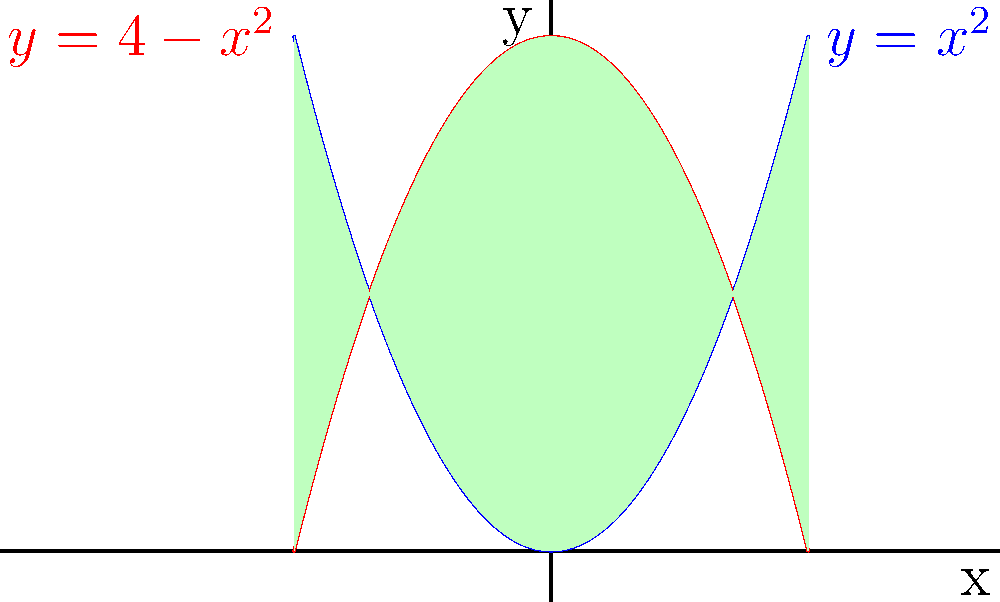At a multicultural school event, you're helping your immigrant friend understand a math problem. The problem involves two parabolas: $y=x^2$ and $y=4-x^2$. What's the area of the region bounded by these two intersecting parabolas? Let's approach this step-by-step:

1) First, we need to find the points of intersection of the two parabolas:
   $x^2 = 4-x^2$
   $2x^2 = 4$
   $x^2 = 2$
   $x = \pm\sqrt{2}$

2) The points of intersection are $(-\sqrt{2},2)$ and $(\sqrt{2},2)$.

3) The area we're looking for is the difference between the integral of the upper function $(4-x^2)$ and the lower function $(x^2)$ from $-\sqrt{2}$ to $\sqrt{2}$:

   $A = \int_{-\sqrt{2}}^{\sqrt{2}} [(4-x^2) - x^2] dx$

4) Simplify the integrand:
   $A = \int_{-\sqrt{2}}^{\sqrt{2}} (4-2x^2) dx$

5) Integrate:
   $A = [4x - \frac{2x^3}{3}]_{-\sqrt{2}}^{\sqrt{2}}$

6) Evaluate the integral:
   $A = (4\sqrt{2} - \frac{2(\sqrt{2})^3}{3}) - (-4\sqrt{2} - \frac{2(-\sqrt{2})^3}{3})$
   $A = 4\sqrt{2} - \frac{4\sqrt{2}}{3} + 4\sqrt{2} + \frac{4\sqrt{2}}{3}$
   $A = 8\sqrt{2}$

7) Therefore, the area is $8\sqrt{2}$ square units.
Answer: $8\sqrt{2}$ square units 